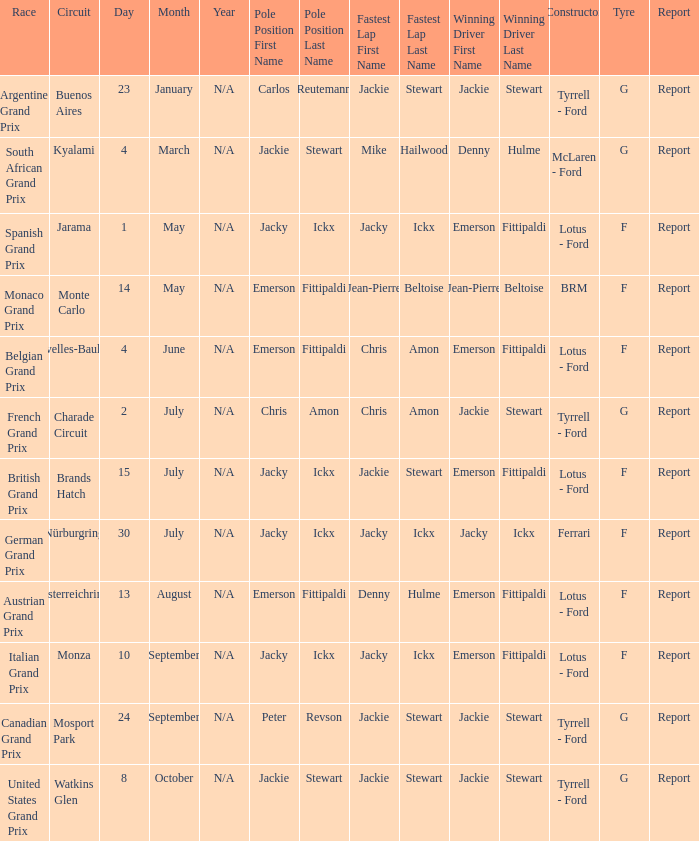What circuit was the British Grand Prix? Brands Hatch. 